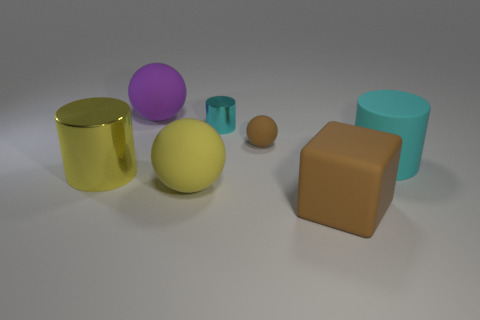If the spheres were to roll, which direction would they go based on the surface? From the image, it appears that the surface is fairly level, so if not influenced by any outside forces, the spheres would likely stay put. However, if there is a slight tilt or disturbance, they might roll towards the direction where their shadows are currently falling, which is to the right in the image. 